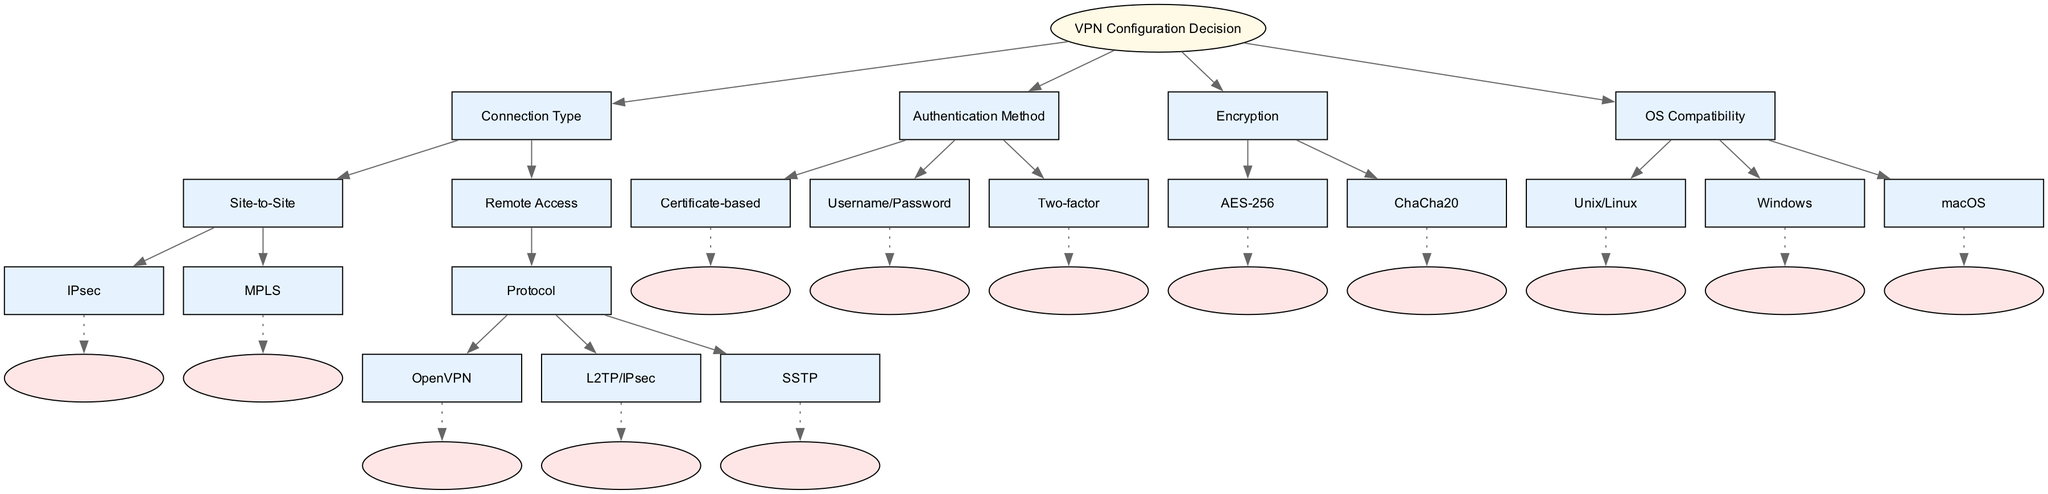What are the two primary connection types in the diagram? The diagram specifies "Site-to-Site" and "Remote Access" as the two main categories of connection types under the root node.
Answer: Site-to-Site, Remote Access How many authentication methods are listed in the diagram? The diagram outlines three authentication methods under the "Authentication Method" node: "Certificate-based," "Username/Password," and "Two-factor." Counting these gives us three methods.
Answer: 3 What encryption options are available according to the diagram? The diagram clearly states "AES-256" and "ChaCha20" under the "Encryption" node, indicating these are the two options provided for encryption methods.
Answer: AES-256, ChaCha20 Which protocol is listed under the remote access category? Under the "Remote Access" node, there is a sub-node labeled "Protocol," which further breaks down into three specific protocols, of which "OpenVPN," "L2TP/IPsec," and "SSTP" are all included.
Answer: OpenVPN, L2TP/IPsec, SSTP Which node leads to the leaf nodes for VPN configurations? Following the decision tree structure, the "Connection Type" node branches into "Site-to-Site" and "Remote Access," where the latter leads to "Protocol" that further breaks down into the VPN protocols, ultimately reaching the leaf nodes. Thus, "Connection Type" is the leading node.
Answer: Connection Type What is the total number of leaf nodes present in the diagram? By counting all the leaf nodes listed under their respective parent nodes – two under "Site-to-Site," three under "Remote Access," and three under "Authentication Method," and two under "Encryption," we total them up: 2 + 3 + 3 + 2 = 10 leaf nodes in total.
Answer: 10 How many operating systems are mentioned in the diagram? The diagram includes three operating systems under the "OS Compatibility" node: "Unix/Linux," "Windows," and "macOS." Therefore, there are three distinct operating systems listed.
Answer: 3 What are the two main types of VPN configurations based on authentication? The types based on authentication as per the diagram are "Certificate-based," "Username/Password," and "Two-factor." To directly answer: the two main types indicated here are "Certificate-based" and "Username/Password."
Answer: Certificate-based, Username/Password 